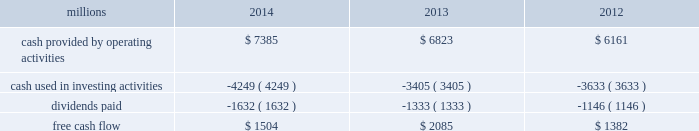Generate cash without additional external financings .
Free cash flow should be considered in addition to , rather than as a substitute for , cash provided by operating activities .
The table reconciles cash provided by operating activities ( gaap measure ) to free cash flow ( non-gaap measure ) : millions 2014 2013 2012 .
2015 outlook f0b7 safety 2013 operating a safe railroad benefits all our constituents : our employees , customers , shareholders and the communities we serve .
We will continue using a multi-faceted approach to safety , utilizing technology , risk assessment , quality control , training and employee engagement , and targeted capital investments .
We will continue using and expanding the deployment of total safety culture and courage to care throughout our operations , which allows us to identify and implement best practices for employee and operational safety .
We will continue our efforts to increase detection of rail defects ; improve or close crossings ; and educate the public and law enforcement agencies about crossing safety through a combination of our own programs ( including risk assessment strategies ) , industry programs and local community activities across our network .
F0b7 network operations 2013 in 2015 , we will continue to add resources to support growth , improve service , and replenish our surge capability .
F0b7 fuel prices 2013 with the dramatic drop in fuel prices at the end of 2014 , there is even more uncertainty around the projections of fuel prices .
We again could see volatile fuel prices during the year , as they are sensitive to global and u.s .
Domestic demand , refining capacity , geopolitical events , weather conditions and other factors .
As prices fluctuate there will be a timing impact on earnings , as our fuel surcharge programs trail fluctuations in fuel price by approximately two months .
Lower fuel prices could have a positive impact on the economy by increasing consumer discretionary spending that potentially could increase demand for various consumer products that we transport .
Alternatively , lower fuel prices will likely have a negative impact on other commodities such as coal , frac sand and crude oil shipments .
F0b7 capital plan 2013 in 2015 , we expect our capital plan to be approximately $ 4.3 billion , including expenditures for ptc and 218 locomotives .
The capital plan may be revised if business conditions warrant or if new laws or regulations affect our ability to generate sufficient returns on these investments .
( see further discussion in this item 7 under liquidity and capital resources 2013 capital plan. ) f0b7 financial expectations 2013 we expect the overall u.s .
Economy to continue to improve at a moderate pace .
One of the biggest uncertainties is the outlook for energy markets , which will bring both challenges and opportunities .
On balance , we expect to see positive volume growth for 2015 versus the prior year .
In the current environment , we expect continued margin improvement driven by continued pricing opportunities , ongoing productivity initiatives and the ability to leverage our resources as we improve the fluidity of our network. .
Is 2014 operating cash flow sufficient to satisfy budgeted 2015 capital expenditures? 
Computations: (7385 > (4.3 * 1000))
Answer: yes. Generate cash without additional external financings .
Free cash flow should be considered in addition to , rather than as a substitute for , cash provided by operating activities .
The table reconciles cash provided by operating activities ( gaap measure ) to free cash flow ( non-gaap measure ) : millions 2014 2013 2012 .
2015 outlook f0b7 safety 2013 operating a safe railroad benefits all our constituents : our employees , customers , shareholders and the communities we serve .
We will continue using a multi-faceted approach to safety , utilizing technology , risk assessment , quality control , training and employee engagement , and targeted capital investments .
We will continue using and expanding the deployment of total safety culture and courage to care throughout our operations , which allows us to identify and implement best practices for employee and operational safety .
We will continue our efforts to increase detection of rail defects ; improve or close crossings ; and educate the public and law enforcement agencies about crossing safety through a combination of our own programs ( including risk assessment strategies ) , industry programs and local community activities across our network .
F0b7 network operations 2013 in 2015 , we will continue to add resources to support growth , improve service , and replenish our surge capability .
F0b7 fuel prices 2013 with the dramatic drop in fuel prices at the end of 2014 , there is even more uncertainty around the projections of fuel prices .
We again could see volatile fuel prices during the year , as they are sensitive to global and u.s .
Domestic demand , refining capacity , geopolitical events , weather conditions and other factors .
As prices fluctuate there will be a timing impact on earnings , as our fuel surcharge programs trail fluctuations in fuel price by approximately two months .
Lower fuel prices could have a positive impact on the economy by increasing consumer discretionary spending that potentially could increase demand for various consumer products that we transport .
Alternatively , lower fuel prices will likely have a negative impact on other commodities such as coal , frac sand and crude oil shipments .
F0b7 capital plan 2013 in 2015 , we expect our capital plan to be approximately $ 4.3 billion , including expenditures for ptc and 218 locomotives .
The capital plan may be revised if business conditions warrant or if new laws or regulations affect our ability to generate sufficient returns on these investments .
( see further discussion in this item 7 under liquidity and capital resources 2013 capital plan. ) f0b7 financial expectations 2013 we expect the overall u.s .
Economy to continue to improve at a moderate pace .
One of the biggest uncertainties is the outlook for energy markets , which will bring both challenges and opportunities .
On balance , we expect to see positive volume growth for 2015 versus the prior year .
In the current environment , we expect continued margin improvement driven by continued pricing opportunities , ongoing productivity initiatives and the ability to leverage our resources as we improve the fluidity of our network. .
What was the percentage change in free cash flow from 2012 to 2013? 
Computations: ((2085 - 1382) / 1382)
Answer: 0.50868. 